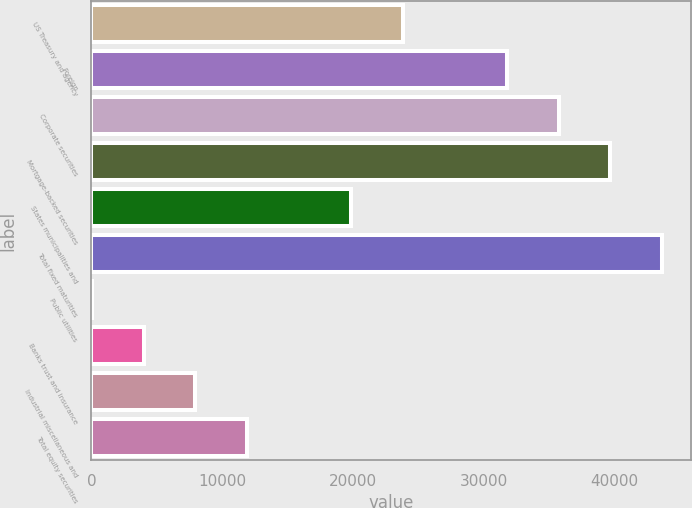Convert chart to OTSL. <chart><loc_0><loc_0><loc_500><loc_500><bar_chart><fcel>US Treasury and agency<fcel>Foreign<fcel>Corporate securities<fcel>Mortgage-backed securities<fcel>States municipalities and<fcel>Total fixed maturities<fcel>Public utilities<fcel>Banks trust and insurance<fcel>Industrial miscellaneous and<fcel>Total equity securities<nl><fcel>23842.4<fcel>31781.2<fcel>35750.6<fcel>39720<fcel>19873<fcel>43689.4<fcel>26<fcel>3995.4<fcel>7964.8<fcel>11934.2<nl></chart> 